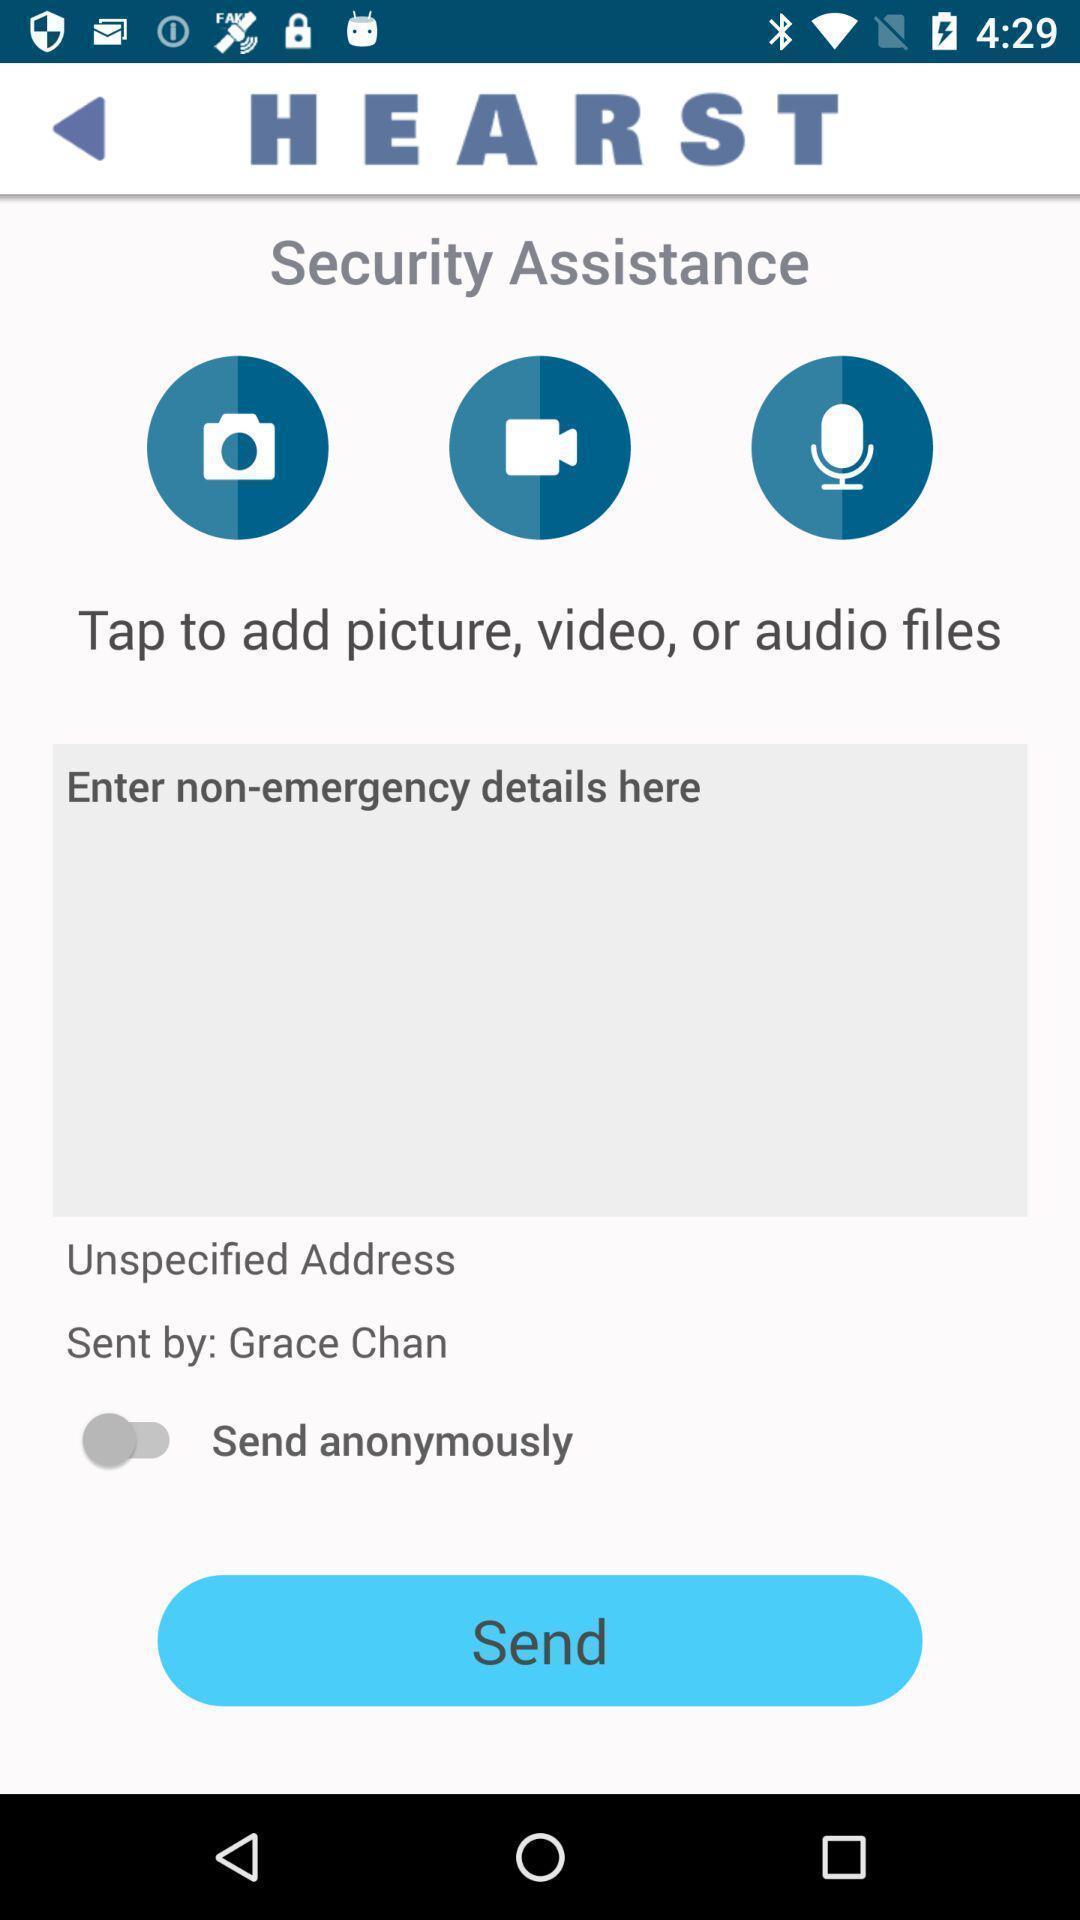Please provide a description for this image. Page with options. 